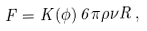Convert formula to latex. <formula><loc_0><loc_0><loc_500><loc_500>F = K ( \phi ) \, 6 \pi \rho \nu R \, ,</formula> 